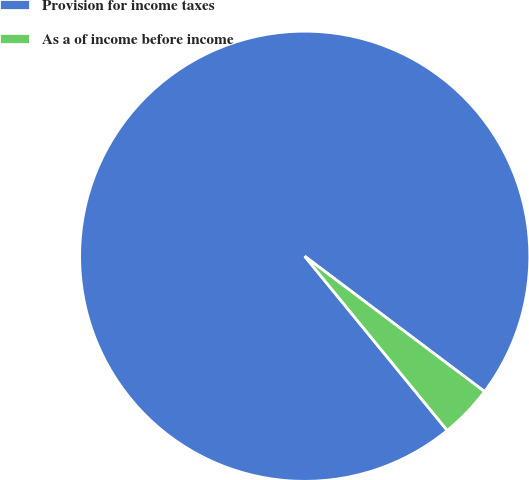<chart> <loc_0><loc_0><loc_500><loc_500><pie_chart><fcel>Provision for income taxes<fcel>As a of income before income<nl><fcel>96.18%<fcel>3.82%<nl></chart> 